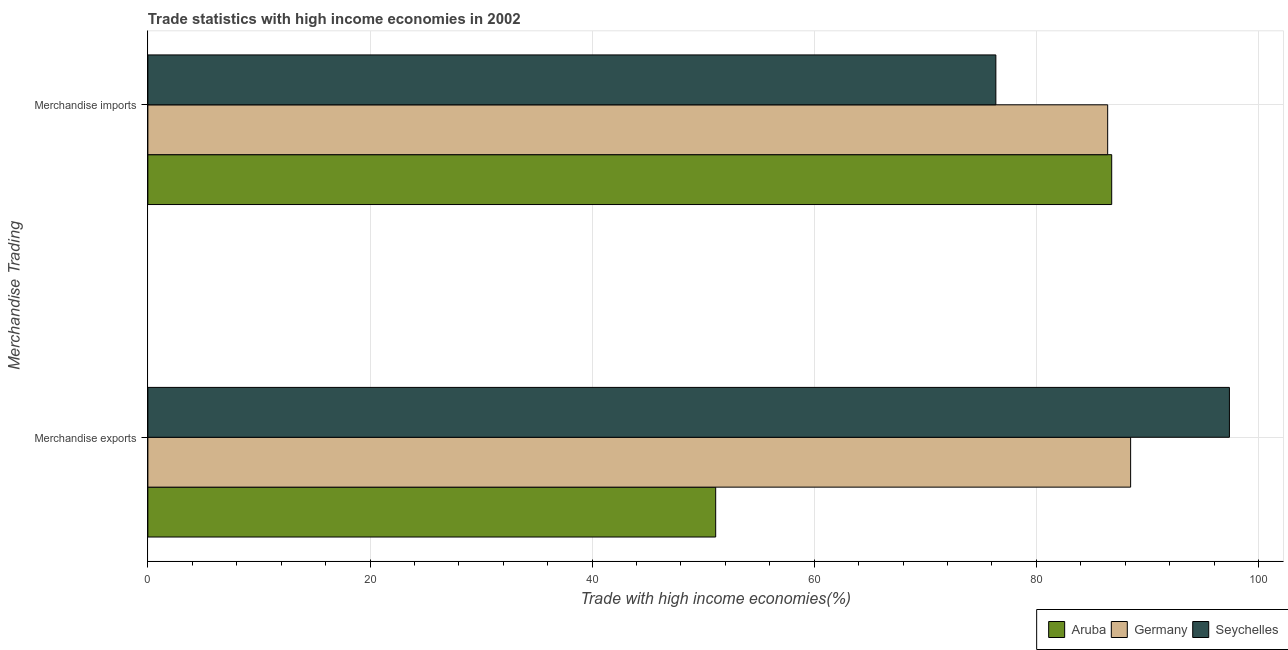How many groups of bars are there?
Provide a short and direct response. 2. Are the number of bars per tick equal to the number of legend labels?
Your answer should be compact. Yes. Are the number of bars on each tick of the Y-axis equal?
Your answer should be very brief. Yes. How many bars are there on the 1st tick from the top?
Give a very brief answer. 3. How many bars are there on the 1st tick from the bottom?
Provide a succinct answer. 3. What is the label of the 2nd group of bars from the top?
Provide a short and direct response. Merchandise exports. What is the merchandise imports in Germany?
Provide a short and direct response. 86.42. Across all countries, what is the maximum merchandise imports?
Keep it short and to the point. 86.78. Across all countries, what is the minimum merchandise imports?
Ensure brevity in your answer.  76.35. In which country was the merchandise exports maximum?
Give a very brief answer. Seychelles. In which country was the merchandise imports minimum?
Give a very brief answer. Seychelles. What is the total merchandise exports in the graph?
Your answer should be very brief. 236.99. What is the difference between the merchandise imports in Aruba and that in Germany?
Offer a terse response. 0.36. What is the difference between the merchandise imports in Seychelles and the merchandise exports in Aruba?
Give a very brief answer. 25.23. What is the average merchandise imports per country?
Make the answer very short. 83.18. What is the difference between the merchandise imports and merchandise exports in Seychelles?
Provide a succinct answer. -21.03. What is the ratio of the merchandise exports in Aruba to that in Seychelles?
Make the answer very short. 0.53. In how many countries, is the merchandise imports greater than the average merchandise imports taken over all countries?
Provide a succinct answer. 2. What does the 3rd bar from the top in Merchandise exports represents?
Provide a succinct answer. Aruba. What does the 1st bar from the bottom in Merchandise imports represents?
Offer a terse response. Aruba. How many bars are there?
Provide a succinct answer. 6. How many countries are there in the graph?
Make the answer very short. 3. What is the difference between two consecutive major ticks on the X-axis?
Make the answer very short. 20. Are the values on the major ticks of X-axis written in scientific E-notation?
Give a very brief answer. No. Does the graph contain any zero values?
Provide a succinct answer. No. Does the graph contain grids?
Make the answer very short. Yes. What is the title of the graph?
Ensure brevity in your answer.  Trade statistics with high income economies in 2002. What is the label or title of the X-axis?
Make the answer very short. Trade with high income economies(%). What is the label or title of the Y-axis?
Make the answer very short. Merchandise Trading. What is the Trade with high income economies(%) in Aruba in Merchandise exports?
Ensure brevity in your answer.  51.13. What is the Trade with high income economies(%) in Germany in Merchandise exports?
Your answer should be very brief. 88.49. What is the Trade with high income economies(%) of Seychelles in Merchandise exports?
Provide a short and direct response. 97.38. What is the Trade with high income economies(%) of Aruba in Merchandise imports?
Give a very brief answer. 86.78. What is the Trade with high income economies(%) in Germany in Merchandise imports?
Ensure brevity in your answer.  86.42. What is the Trade with high income economies(%) in Seychelles in Merchandise imports?
Your answer should be compact. 76.35. Across all Merchandise Trading, what is the maximum Trade with high income economies(%) in Aruba?
Keep it short and to the point. 86.78. Across all Merchandise Trading, what is the maximum Trade with high income economies(%) in Germany?
Give a very brief answer. 88.49. Across all Merchandise Trading, what is the maximum Trade with high income economies(%) in Seychelles?
Your response must be concise. 97.38. Across all Merchandise Trading, what is the minimum Trade with high income economies(%) in Aruba?
Make the answer very short. 51.13. Across all Merchandise Trading, what is the minimum Trade with high income economies(%) of Germany?
Make the answer very short. 86.42. Across all Merchandise Trading, what is the minimum Trade with high income economies(%) of Seychelles?
Keep it short and to the point. 76.35. What is the total Trade with high income economies(%) in Aruba in the graph?
Give a very brief answer. 137.91. What is the total Trade with high income economies(%) of Germany in the graph?
Make the answer very short. 174.9. What is the total Trade with high income economies(%) of Seychelles in the graph?
Offer a very short reply. 173.73. What is the difference between the Trade with high income economies(%) in Aruba in Merchandise exports and that in Merchandise imports?
Ensure brevity in your answer.  -35.66. What is the difference between the Trade with high income economies(%) in Germany in Merchandise exports and that in Merchandise imports?
Offer a very short reply. 2.07. What is the difference between the Trade with high income economies(%) of Seychelles in Merchandise exports and that in Merchandise imports?
Your answer should be very brief. 21.03. What is the difference between the Trade with high income economies(%) of Aruba in Merchandise exports and the Trade with high income economies(%) of Germany in Merchandise imports?
Keep it short and to the point. -35.29. What is the difference between the Trade with high income economies(%) in Aruba in Merchandise exports and the Trade with high income economies(%) in Seychelles in Merchandise imports?
Provide a short and direct response. -25.23. What is the difference between the Trade with high income economies(%) in Germany in Merchandise exports and the Trade with high income economies(%) in Seychelles in Merchandise imports?
Your answer should be compact. 12.13. What is the average Trade with high income economies(%) in Aruba per Merchandise Trading?
Keep it short and to the point. 68.95. What is the average Trade with high income economies(%) of Germany per Merchandise Trading?
Keep it short and to the point. 87.45. What is the average Trade with high income economies(%) in Seychelles per Merchandise Trading?
Give a very brief answer. 86.87. What is the difference between the Trade with high income economies(%) of Aruba and Trade with high income economies(%) of Germany in Merchandise exports?
Your response must be concise. -37.36. What is the difference between the Trade with high income economies(%) in Aruba and Trade with high income economies(%) in Seychelles in Merchandise exports?
Your answer should be compact. -46.25. What is the difference between the Trade with high income economies(%) in Germany and Trade with high income economies(%) in Seychelles in Merchandise exports?
Offer a very short reply. -8.89. What is the difference between the Trade with high income economies(%) of Aruba and Trade with high income economies(%) of Germany in Merchandise imports?
Give a very brief answer. 0.36. What is the difference between the Trade with high income economies(%) in Aruba and Trade with high income economies(%) in Seychelles in Merchandise imports?
Your answer should be compact. 10.43. What is the difference between the Trade with high income economies(%) of Germany and Trade with high income economies(%) of Seychelles in Merchandise imports?
Make the answer very short. 10.07. What is the ratio of the Trade with high income economies(%) of Aruba in Merchandise exports to that in Merchandise imports?
Keep it short and to the point. 0.59. What is the ratio of the Trade with high income economies(%) in Germany in Merchandise exports to that in Merchandise imports?
Provide a succinct answer. 1.02. What is the ratio of the Trade with high income economies(%) of Seychelles in Merchandise exports to that in Merchandise imports?
Provide a succinct answer. 1.28. What is the difference between the highest and the second highest Trade with high income economies(%) of Aruba?
Your answer should be very brief. 35.66. What is the difference between the highest and the second highest Trade with high income economies(%) in Germany?
Give a very brief answer. 2.07. What is the difference between the highest and the second highest Trade with high income economies(%) of Seychelles?
Your answer should be very brief. 21.03. What is the difference between the highest and the lowest Trade with high income economies(%) of Aruba?
Give a very brief answer. 35.66. What is the difference between the highest and the lowest Trade with high income economies(%) in Germany?
Offer a very short reply. 2.07. What is the difference between the highest and the lowest Trade with high income economies(%) in Seychelles?
Provide a succinct answer. 21.03. 